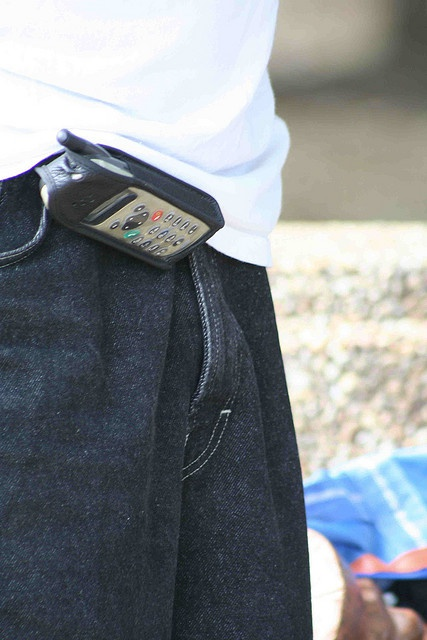Describe the objects in this image and their specific colors. I can see people in white, black, and darkblue tones and cell phone in white, black, gray, darkgray, and darkblue tones in this image. 